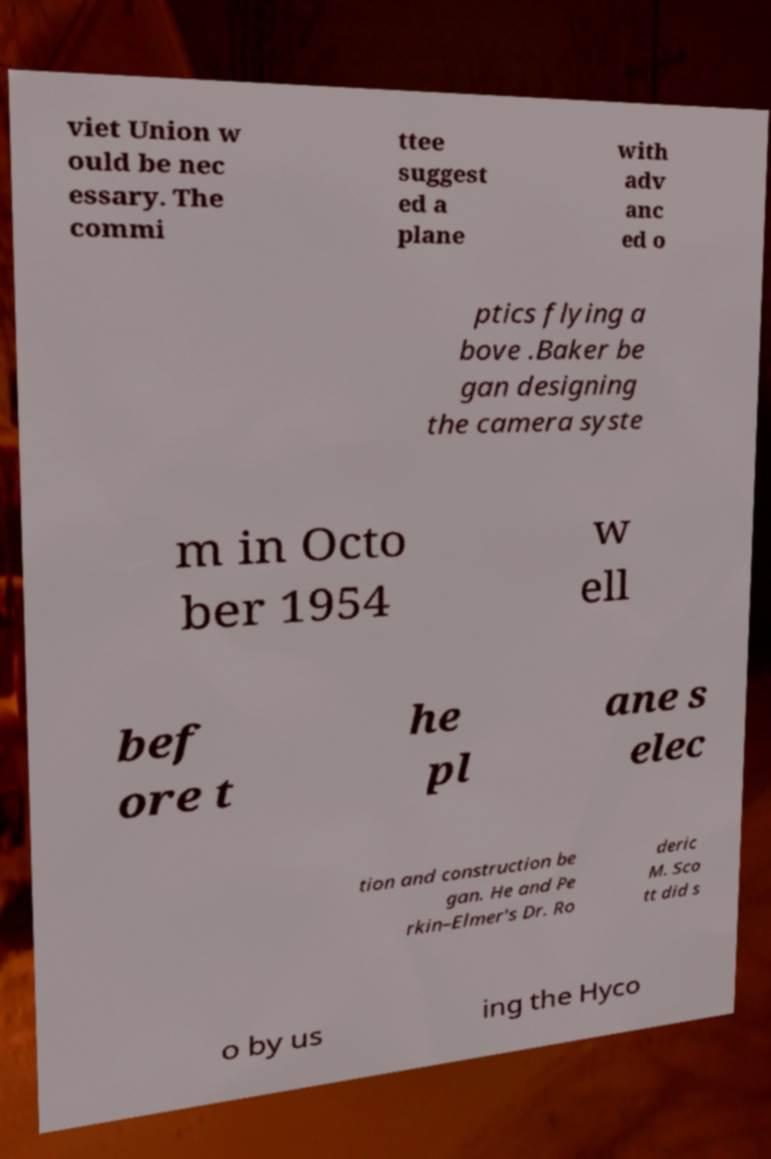For documentation purposes, I need the text within this image transcribed. Could you provide that? viet Union w ould be nec essary. The commi ttee suggest ed a plane with adv anc ed o ptics flying a bove .Baker be gan designing the camera syste m in Octo ber 1954 w ell bef ore t he pl ane s elec tion and construction be gan. He and Pe rkin–Elmer's Dr. Ro deric M. Sco tt did s o by us ing the Hyco 